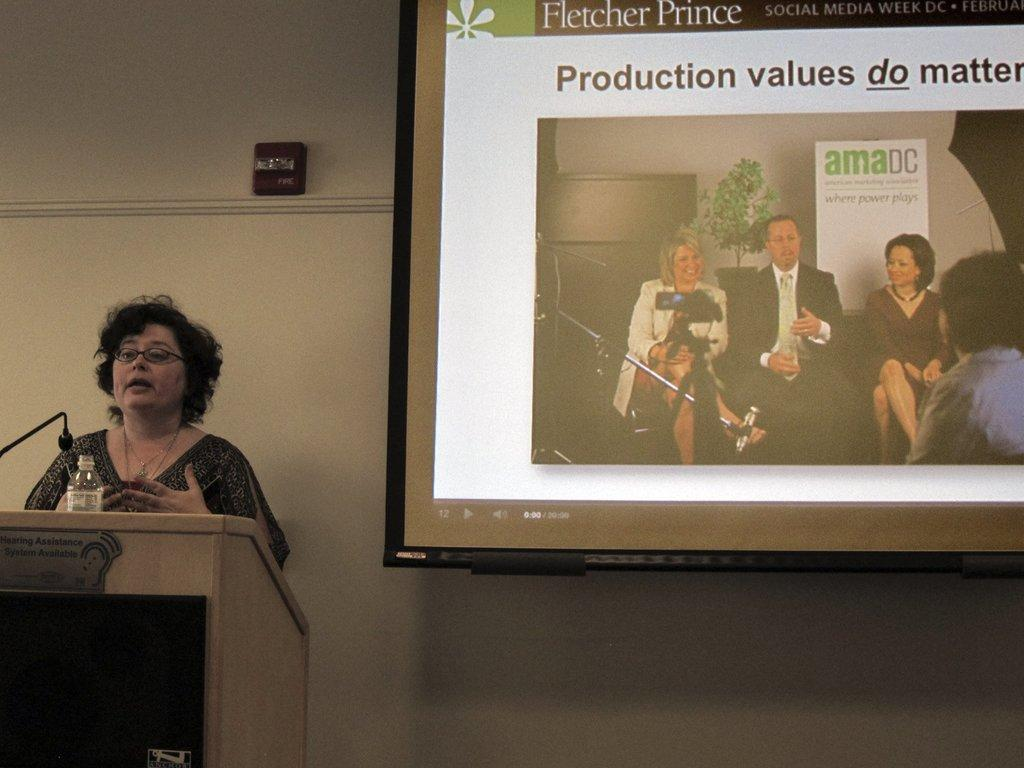What is the lady doing in the image? The lady is standing on the left side of the image and talking. What is in front of the lady? There is a podium before the lady. What is used for amplifying the lady's voice in the image? A: A microphone (mic) is present. What is located in the center of the image? There is a screen in the center of the image. What is visible in the background of the image? There is a wall in the image. What type of vest is the lady wearing in the image? There is no vest visible in the image; the lady is not wearing any clothing mentioned in the facts. 